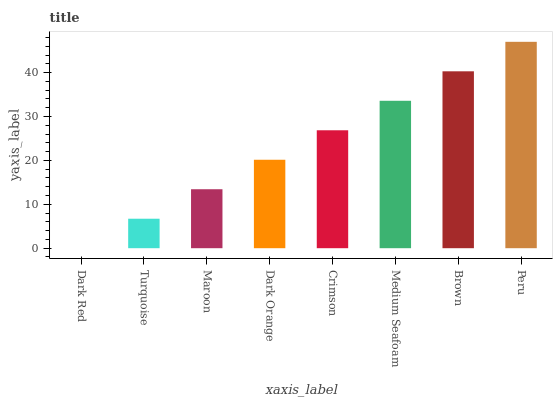Is Dark Red the minimum?
Answer yes or no. Yes. Is Peru the maximum?
Answer yes or no. Yes. Is Turquoise the minimum?
Answer yes or no. No. Is Turquoise the maximum?
Answer yes or no. No. Is Turquoise greater than Dark Red?
Answer yes or no. Yes. Is Dark Red less than Turquoise?
Answer yes or no. Yes. Is Dark Red greater than Turquoise?
Answer yes or no. No. Is Turquoise less than Dark Red?
Answer yes or no. No. Is Crimson the high median?
Answer yes or no. Yes. Is Dark Orange the low median?
Answer yes or no. Yes. Is Dark Red the high median?
Answer yes or no. No. Is Peru the low median?
Answer yes or no. No. 